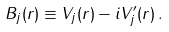Convert formula to latex. <formula><loc_0><loc_0><loc_500><loc_500>B _ { j } ( { r } ) \equiv V _ { j } ( { r } ) - i V _ { j } ^ { \prime } ( { r } ) \, .</formula> 